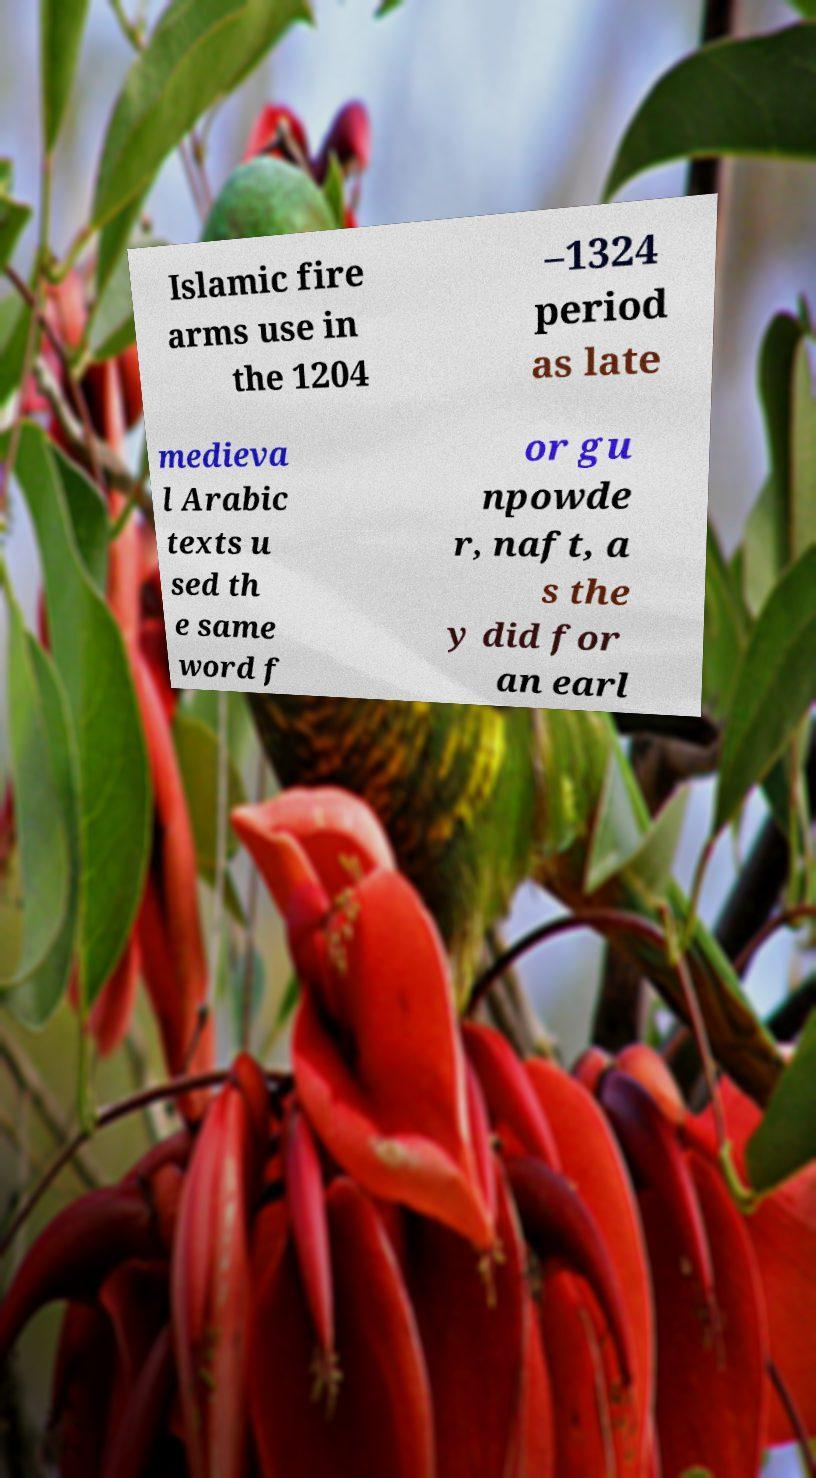What messages or text are displayed in this image? I need them in a readable, typed format. Islamic fire arms use in the 1204 –1324 period as late medieva l Arabic texts u sed th e same word f or gu npowde r, naft, a s the y did for an earl 